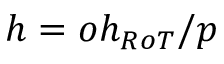Convert formula to latex. <formula><loc_0><loc_0><loc_500><loc_500>h = o h _ { R o T } / p</formula> 